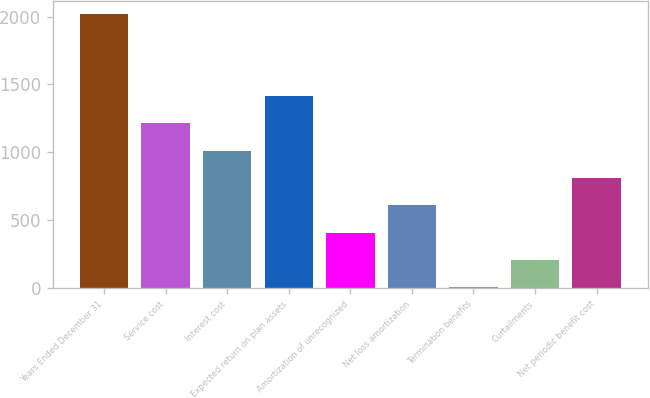Convert chart. <chart><loc_0><loc_0><loc_500><loc_500><bar_chart><fcel>Years Ended December 31<fcel>Service cost<fcel>Interest cost<fcel>Expected return on plan assets<fcel>Amortization of unrecognized<fcel>Net loss amortization<fcel>Termination benefits<fcel>Curtailments<fcel>Net periodic benefit cost<nl><fcel>2017<fcel>1211.8<fcel>1010.5<fcel>1413.1<fcel>406.6<fcel>607.9<fcel>4<fcel>205.3<fcel>809.2<nl></chart> 